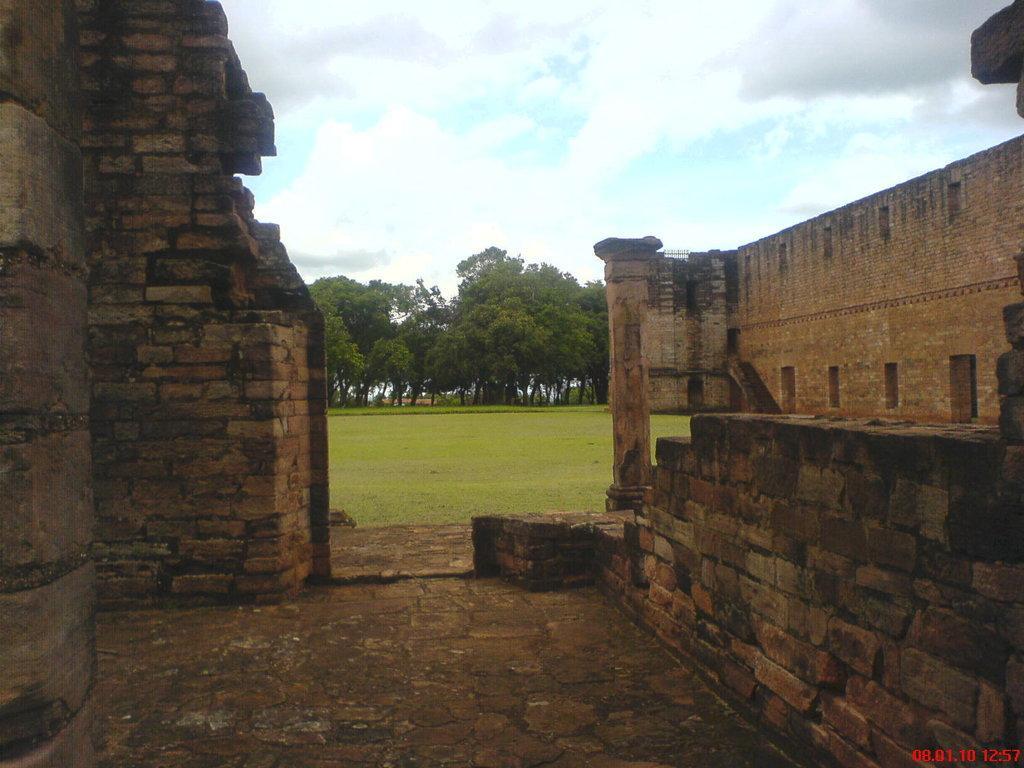Could you give a brief overview of what you see in this image? In this picture we can see walls, pillar and grass. In the background of the image we can see trees and sky with clouds. In the bottom right side of the image we can see time and date. 